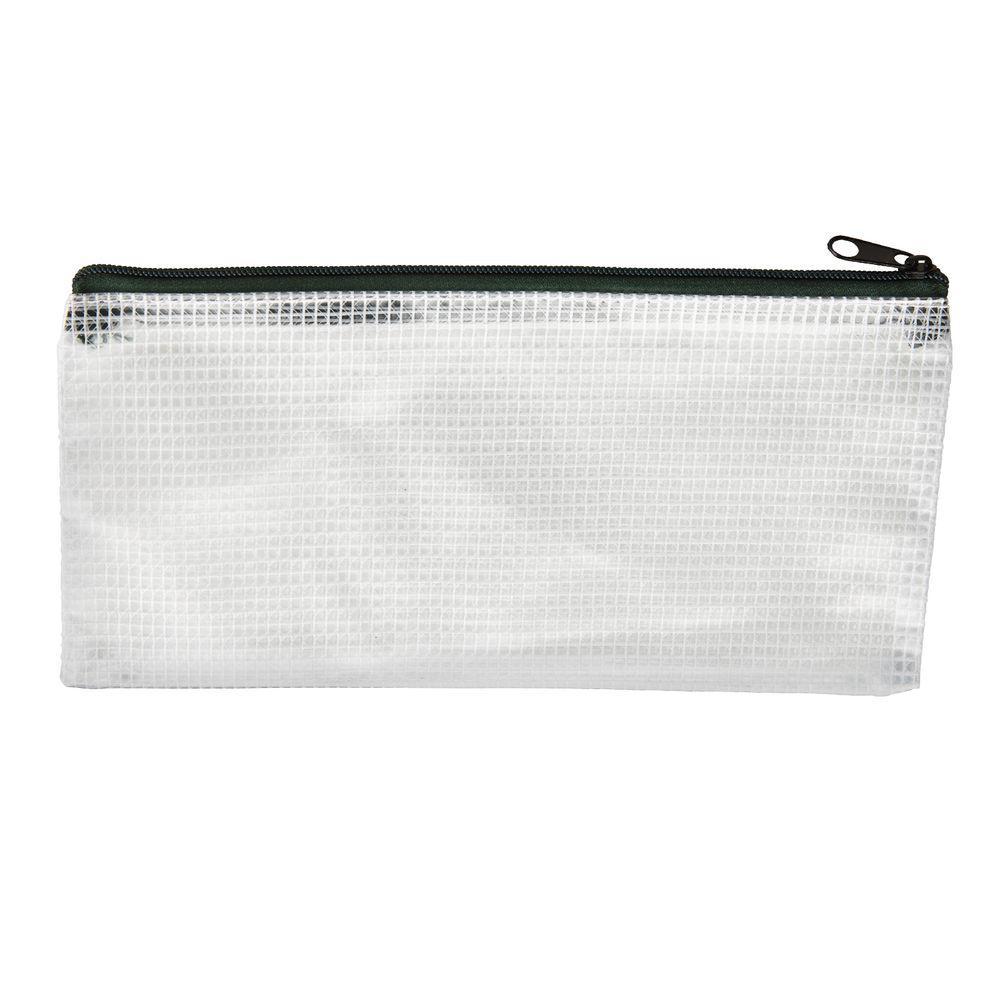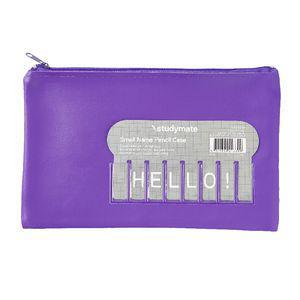The first image is the image on the left, the second image is the image on the right. Considering the images on both sides, is "Each case has a single zipper and a rectangular shape with non-rounded bottom corners, and one case has a gray card on the front." valid? Answer yes or no. Yes. The first image is the image on the left, the second image is the image on the right. For the images shown, is this caption "There is a grey tag on the pencil case in one of the images." true? Answer yes or no. Yes. 